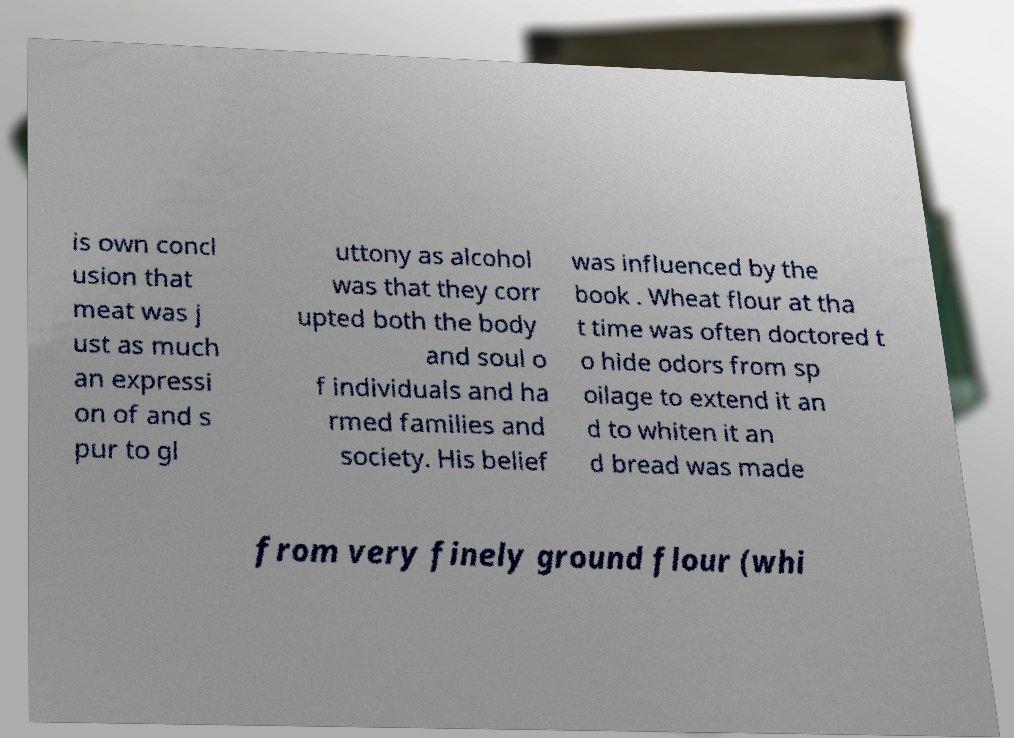There's text embedded in this image that I need extracted. Can you transcribe it verbatim? is own concl usion that meat was j ust as much an expressi on of and s pur to gl uttony as alcohol was that they corr upted both the body and soul o f individuals and ha rmed families and society. His belief was influenced by the book . Wheat flour at tha t time was often doctored t o hide odors from sp oilage to extend it an d to whiten it an d bread was made from very finely ground flour (whi 